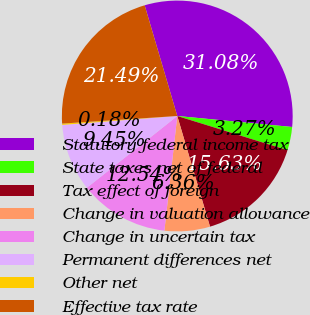Convert chart. <chart><loc_0><loc_0><loc_500><loc_500><pie_chart><fcel>Statutory federal income tax<fcel>State taxes net of federal<fcel>Tax effect of foreign<fcel>Change in valuation allowance<fcel>Change in uncertain tax<fcel>Permanent differences net<fcel>Other net<fcel>Effective tax rate<nl><fcel>31.08%<fcel>3.27%<fcel>15.63%<fcel>6.36%<fcel>12.54%<fcel>9.45%<fcel>0.18%<fcel>21.49%<nl></chart> 